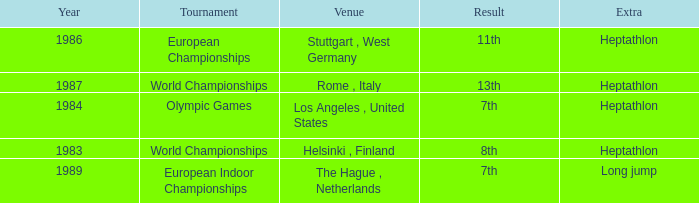Where was the 1984 Olympics hosted? Olympic Games. 